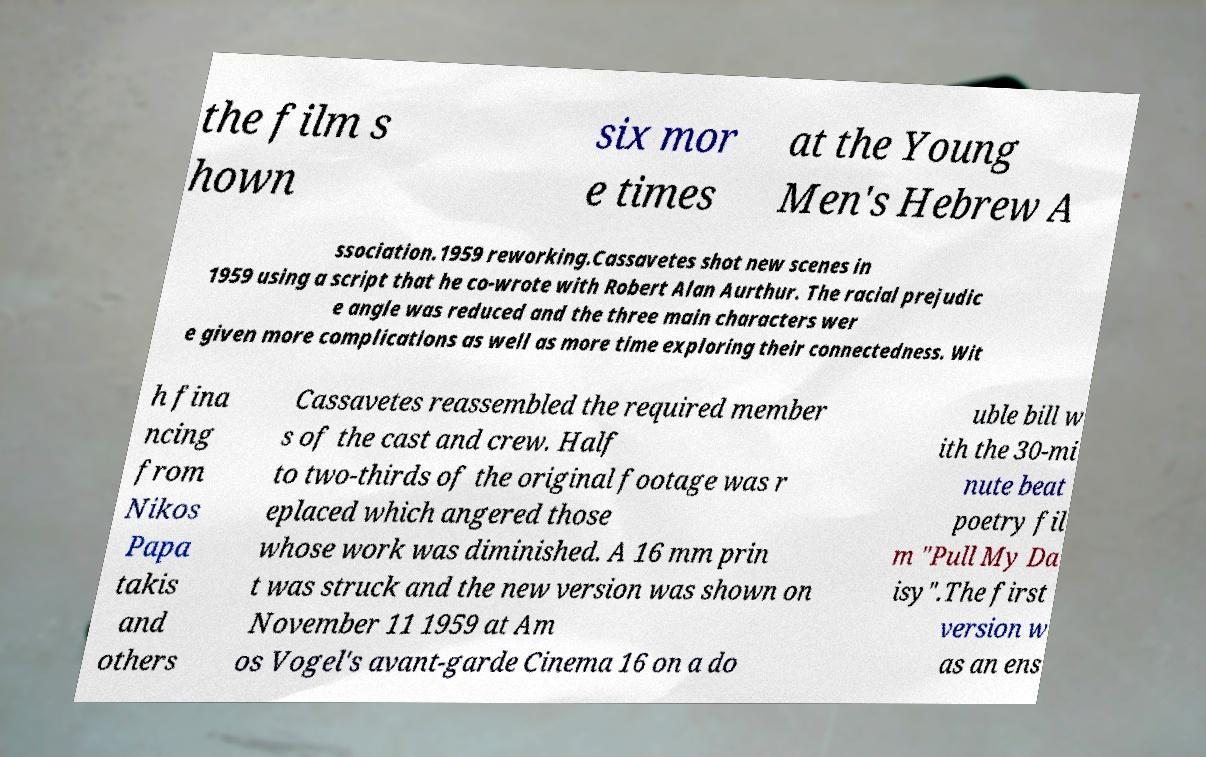Could you extract and type out the text from this image? the film s hown six mor e times at the Young Men's Hebrew A ssociation.1959 reworking.Cassavetes shot new scenes in 1959 using a script that he co-wrote with Robert Alan Aurthur. The racial prejudic e angle was reduced and the three main characters wer e given more complications as well as more time exploring their connectedness. Wit h fina ncing from Nikos Papa takis and others Cassavetes reassembled the required member s of the cast and crew. Half to two-thirds of the original footage was r eplaced which angered those whose work was diminished. A 16 mm prin t was struck and the new version was shown on November 11 1959 at Am os Vogel's avant-garde Cinema 16 on a do uble bill w ith the 30-mi nute beat poetry fil m "Pull My Da isy".The first version w as an ens 